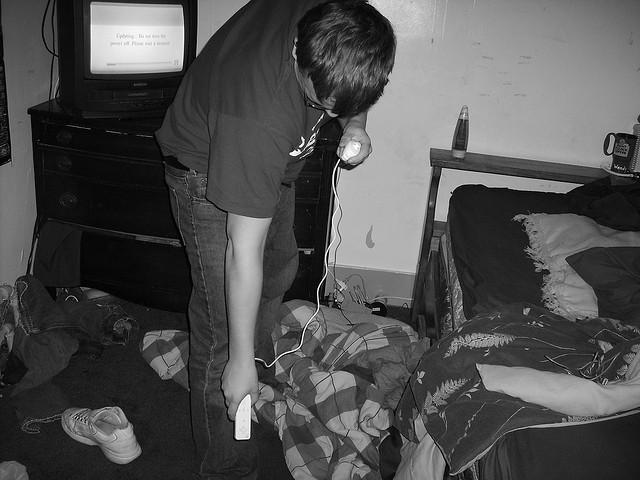What is the video game console connected to the television currently doing?
Answer the question by selecting the correct answer among the 4 following choices.
Options: Updating, formatting, rebooting, starting. Updating. 